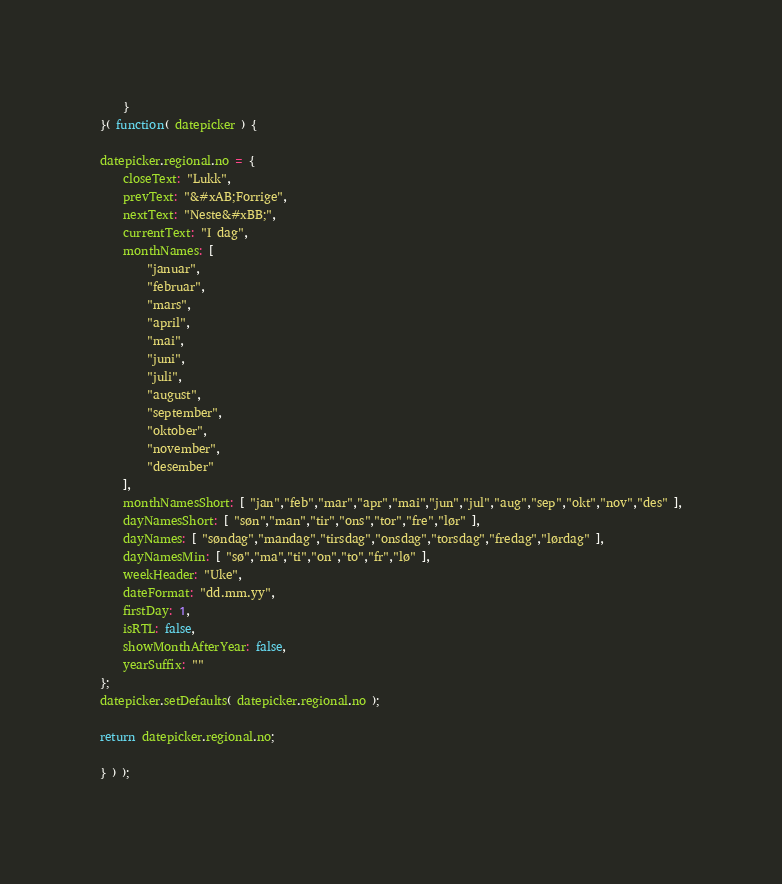Convert code to text. <code><loc_0><loc_0><loc_500><loc_500><_JavaScript_>	}
}( function( datepicker ) {

datepicker.regional.no = {
	closeText: "Lukk",
	prevText: "&#xAB;Forrige",
	nextText: "Neste&#xBB;",
	currentText: "I dag",
	monthNames: [
		"januar",
		"februar",
		"mars",
		"april",
		"mai",
		"juni",
		"juli",
		"august",
		"september",
		"oktober",
		"november",
		"desember"
	],
	monthNamesShort: [ "jan","feb","mar","apr","mai","jun","jul","aug","sep","okt","nov","des" ],
	dayNamesShort: [ "søn","man","tir","ons","tor","fre","lør" ],
	dayNames: [ "søndag","mandag","tirsdag","onsdag","torsdag","fredag","lørdag" ],
	dayNamesMin: [ "sø","ma","ti","on","to","fr","lø" ],
	weekHeader: "Uke",
	dateFormat: "dd.mm.yy",
	firstDay: 1,
	isRTL: false,
	showMonthAfterYear: false,
	yearSuffix: ""
};
datepicker.setDefaults( datepicker.regional.no );

return datepicker.regional.no;

} ) );
</code> 